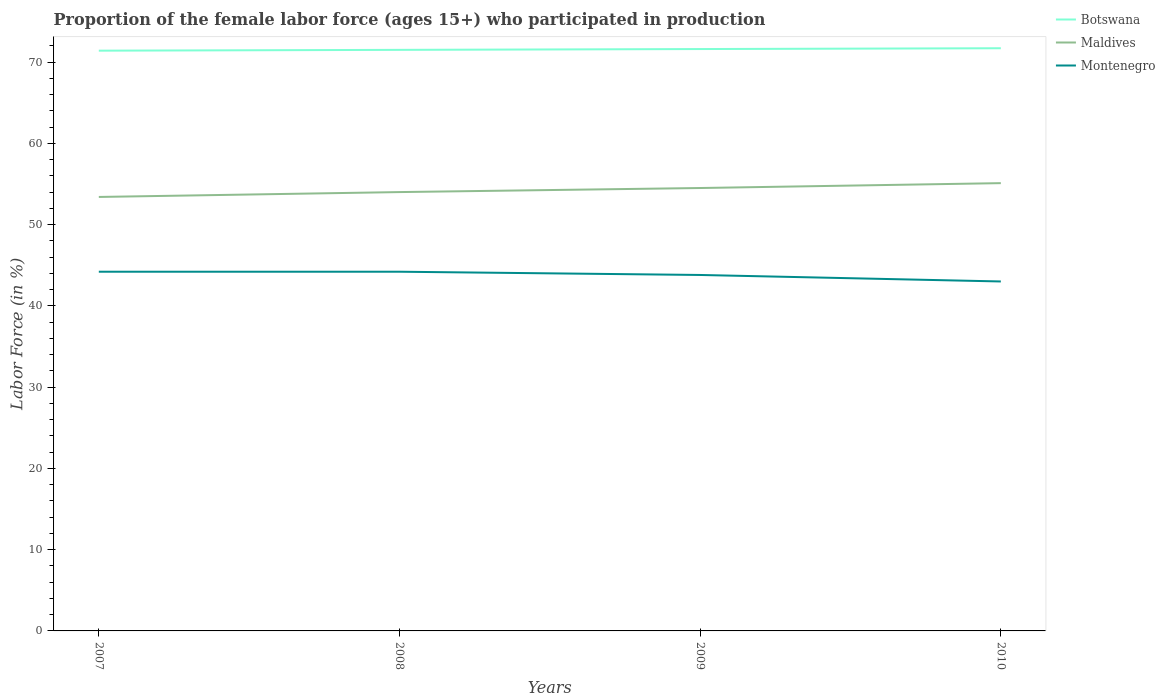Does the line corresponding to Montenegro intersect with the line corresponding to Botswana?
Ensure brevity in your answer.  No. Is the number of lines equal to the number of legend labels?
Give a very brief answer. Yes. Across all years, what is the maximum proportion of the female labor force who participated in production in Botswana?
Your answer should be very brief. 71.4. What is the total proportion of the female labor force who participated in production in Botswana in the graph?
Ensure brevity in your answer.  -0.1. What is the difference between the highest and the second highest proportion of the female labor force who participated in production in Montenegro?
Your answer should be very brief. 1.2. Is the proportion of the female labor force who participated in production in Botswana strictly greater than the proportion of the female labor force who participated in production in Montenegro over the years?
Your response must be concise. No. How many lines are there?
Offer a terse response. 3. Does the graph contain any zero values?
Keep it short and to the point. No. Does the graph contain grids?
Give a very brief answer. No. How are the legend labels stacked?
Offer a very short reply. Vertical. What is the title of the graph?
Keep it short and to the point. Proportion of the female labor force (ages 15+) who participated in production. What is the Labor Force (in %) of Botswana in 2007?
Offer a very short reply. 71.4. What is the Labor Force (in %) in Maldives in 2007?
Make the answer very short. 53.4. What is the Labor Force (in %) in Montenegro in 2007?
Keep it short and to the point. 44.2. What is the Labor Force (in %) in Botswana in 2008?
Make the answer very short. 71.5. What is the Labor Force (in %) of Montenegro in 2008?
Provide a short and direct response. 44.2. What is the Labor Force (in %) in Botswana in 2009?
Ensure brevity in your answer.  71.6. What is the Labor Force (in %) in Maldives in 2009?
Offer a terse response. 54.5. What is the Labor Force (in %) of Montenegro in 2009?
Keep it short and to the point. 43.8. What is the Labor Force (in %) of Botswana in 2010?
Keep it short and to the point. 71.7. What is the Labor Force (in %) in Maldives in 2010?
Keep it short and to the point. 55.1. What is the Labor Force (in %) of Montenegro in 2010?
Make the answer very short. 43. Across all years, what is the maximum Labor Force (in %) in Botswana?
Your response must be concise. 71.7. Across all years, what is the maximum Labor Force (in %) of Maldives?
Offer a very short reply. 55.1. Across all years, what is the maximum Labor Force (in %) in Montenegro?
Offer a terse response. 44.2. Across all years, what is the minimum Labor Force (in %) in Botswana?
Offer a terse response. 71.4. Across all years, what is the minimum Labor Force (in %) in Maldives?
Provide a short and direct response. 53.4. What is the total Labor Force (in %) of Botswana in the graph?
Your answer should be compact. 286.2. What is the total Labor Force (in %) in Maldives in the graph?
Your response must be concise. 217. What is the total Labor Force (in %) in Montenegro in the graph?
Offer a very short reply. 175.2. What is the difference between the Labor Force (in %) of Botswana in 2007 and that in 2008?
Provide a short and direct response. -0.1. What is the difference between the Labor Force (in %) of Maldives in 2007 and that in 2008?
Provide a succinct answer. -0.6. What is the difference between the Labor Force (in %) in Montenegro in 2007 and that in 2008?
Ensure brevity in your answer.  0. What is the difference between the Labor Force (in %) of Botswana in 2007 and that in 2009?
Your response must be concise. -0.2. What is the difference between the Labor Force (in %) of Maldives in 2007 and that in 2009?
Provide a short and direct response. -1.1. What is the difference between the Labor Force (in %) in Maldives in 2007 and that in 2010?
Ensure brevity in your answer.  -1.7. What is the difference between the Labor Force (in %) of Botswana in 2008 and that in 2010?
Keep it short and to the point. -0.2. What is the difference between the Labor Force (in %) in Maldives in 2008 and that in 2010?
Your response must be concise. -1.1. What is the difference between the Labor Force (in %) of Montenegro in 2008 and that in 2010?
Offer a very short reply. 1.2. What is the difference between the Labor Force (in %) of Botswana in 2009 and that in 2010?
Your answer should be very brief. -0.1. What is the difference between the Labor Force (in %) in Montenegro in 2009 and that in 2010?
Provide a succinct answer. 0.8. What is the difference between the Labor Force (in %) in Botswana in 2007 and the Labor Force (in %) in Montenegro in 2008?
Keep it short and to the point. 27.2. What is the difference between the Labor Force (in %) of Maldives in 2007 and the Labor Force (in %) of Montenegro in 2008?
Ensure brevity in your answer.  9.2. What is the difference between the Labor Force (in %) of Botswana in 2007 and the Labor Force (in %) of Montenegro in 2009?
Provide a short and direct response. 27.6. What is the difference between the Labor Force (in %) of Maldives in 2007 and the Labor Force (in %) of Montenegro in 2009?
Offer a terse response. 9.6. What is the difference between the Labor Force (in %) in Botswana in 2007 and the Labor Force (in %) in Maldives in 2010?
Provide a short and direct response. 16.3. What is the difference between the Labor Force (in %) in Botswana in 2007 and the Labor Force (in %) in Montenegro in 2010?
Give a very brief answer. 28.4. What is the difference between the Labor Force (in %) in Botswana in 2008 and the Labor Force (in %) in Maldives in 2009?
Your response must be concise. 17. What is the difference between the Labor Force (in %) of Botswana in 2008 and the Labor Force (in %) of Montenegro in 2009?
Make the answer very short. 27.7. What is the difference between the Labor Force (in %) of Botswana in 2008 and the Labor Force (in %) of Maldives in 2010?
Keep it short and to the point. 16.4. What is the difference between the Labor Force (in %) in Maldives in 2008 and the Labor Force (in %) in Montenegro in 2010?
Ensure brevity in your answer.  11. What is the difference between the Labor Force (in %) of Botswana in 2009 and the Labor Force (in %) of Montenegro in 2010?
Make the answer very short. 28.6. What is the average Labor Force (in %) of Botswana per year?
Provide a succinct answer. 71.55. What is the average Labor Force (in %) of Maldives per year?
Make the answer very short. 54.25. What is the average Labor Force (in %) of Montenegro per year?
Keep it short and to the point. 43.8. In the year 2007, what is the difference between the Labor Force (in %) in Botswana and Labor Force (in %) in Montenegro?
Make the answer very short. 27.2. In the year 2007, what is the difference between the Labor Force (in %) in Maldives and Labor Force (in %) in Montenegro?
Your answer should be compact. 9.2. In the year 2008, what is the difference between the Labor Force (in %) of Botswana and Labor Force (in %) of Montenegro?
Provide a short and direct response. 27.3. In the year 2008, what is the difference between the Labor Force (in %) of Maldives and Labor Force (in %) of Montenegro?
Give a very brief answer. 9.8. In the year 2009, what is the difference between the Labor Force (in %) in Botswana and Labor Force (in %) in Montenegro?
Your answer should be compact. 27.8. In the year 2009, what is the difference between the Labor Force (in %) in Maldives and Labor Force (in %) in Montenegro?
Your response must be concise. 10.7. In the year 2010, what is the difference between the Labor Force (in %) of Botswana and Labor Force (in %) of Maldives?
Provide a succinct answer. 16.6. In the year 2010, what is the difference between the Labor Force (in %) in Botswana and Labor Force (in %) in Montenegro?
Your response must be concise. 28.7. In the year 2010, what is the difference between the Labor Force (in %) in Maldives and Labor Force (in %) in Montenegro?
Your answer should be very brief. 12.1. What is the ratio of the Labor Force (in %) of Maldives in 2007 to that in 2008?
Your answer should be compact. 0.99. What is the ratio of the Labor Force (in %) of Montenegro in 2007 to that in 2008?
Ensure brevity in your answer.  1. What is the ratio of the Labor Force (in %) in Maldives in 2007 to that in 2009?
Provide a short and direct response. 0.98. What is the ratio of the Labor Force (in %) of Montenegro in 2007 to that in 2009?
Offer a terse response. 1.01. What is the ratio of the Labor Force (in %) in Maldives in 2007 to that in 2010?
Make the answer very short. 0.97. What is the ratio of the Labor Force (in %) of Montenegro in 2007 to that in 2010?
Offer a very short reply. 1.03. What is the ratio of the Labor Force (in %) in Montenegro in 2008 to that in 2009?
Your answer should be very brief. 1.01. What is the ratio of the Labor Force (in %) of Montenegro in 2008 to that in 2010?
Keep it short and to the point. 1.03. What is the ratio of the Labor Force (in %) in Montenegro in 2009 to that in 2010?
Ensure brevity in your answer.  1.02. What is the difference between the highest and the second highest Labor Force (in %) in Botswana?
Your response must be concise. 0.1. What is the difference between the highest and the second highest Labor Force (in %) of Maldives?
Your answer should be compact. 0.6. What is the difference between the highest and the lowest Labor Force (in %) in Botswana?
Offer a terse response. 0.3. 